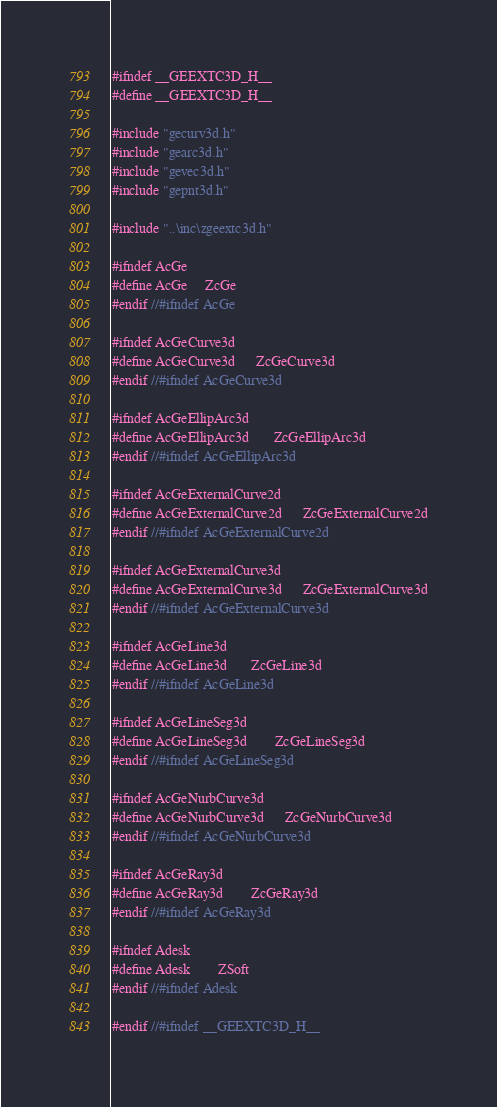<code> <loc_0><loc_0><loc_500><loc_500><_C_>
#ifndef __GEEXTC3D_H__
#define __GEEXTC3D_H__

#include "gecurv3d.h"
#include "gearc3d.h"
#include "gevec3d.h"
#include "gepnt3d.h"

#include "..\inc\zgeextc3d.h"

#ifndef AcGe
#define AcGe		ZcGe
#endif //#ifndef AcGe

#ifndef AcGeCurve3d
#define AcGeCurve3d		ZcGeCurve3d
#endif //#ifndef AcGeCurve3d

#ifndef AcGeEllipArc3d
#define AcGeEllipArc3d		ZcGeEllipArc3d
#endif //#ifndef AcGeEllipArc3d

#ifndef AcGeExternalCurve2d
#define AcGeExternalCurve2d		ZcGeExternalCurve2d
#endif //#ifndef AcGeExternalCurve2d

#ifndef AcGeExternalCurve3d
#define AcGeExternalCurve3d		ZcGeExternalCurve3d
#endif //#ifndef AcGeExternalCurve3d

#ifndef AcGeLine3d
#define AcGeLine3d		ZcGeLine3d
#endif //#ifndef AcGeLine3d

#ifndef AcGeLineSeg3d
#define AcGeLineSeg3d		ZcGeLineSeg3d
#endif //#ifndef AcGeLineSeg3d

#ifndef AcGeNurbCurve3d
#define AcGeNurbCurve3d		ZcGeNurbCurve3d
#endif //#ifndef AcGeNurbCurve3d

#ifndef AcGeRay3d
#define AcGeRay3d		ZcGeRay3d
#endif //#ifndef AcGeRay3d

#ifndef Adesk
#define Adesk		ZSoft
#endif //#ifndef Adesk

#endif //#ifndef __GEEXTC3D_H__
</code> 